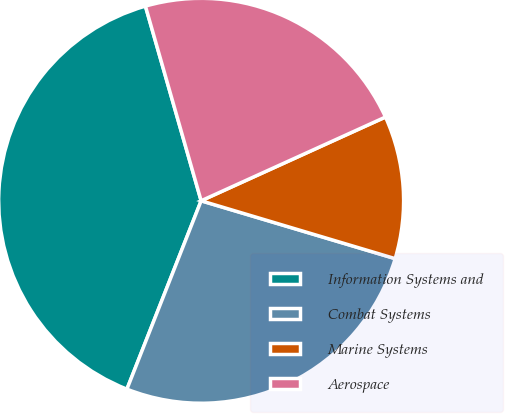Convert chart to OTSL. <chart><loc_0><loc_0><loc_500><loc_500><pie_chart><fcel>Information Systems and<fcel>Combat Systems<fcel>Marine Systems<fcel>Aerospace<nl><fcel>39.59%<fcel>26.36%<fcel>11.4%<fcel>22.65%<nl></chart> 